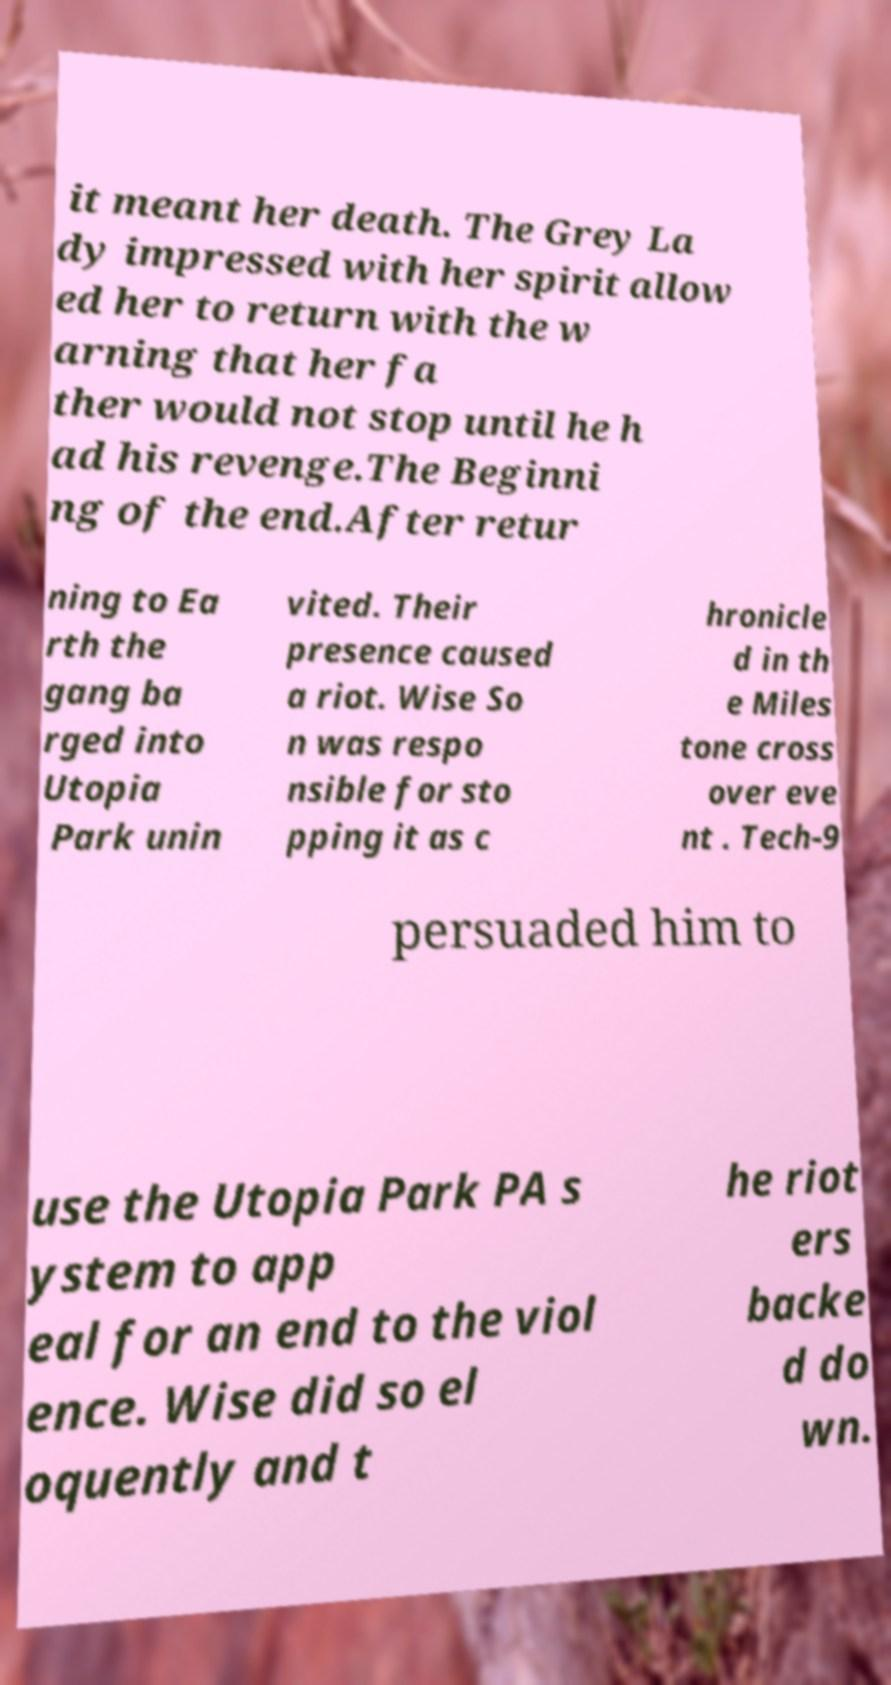For documentation purposes, I need the text within this image transcribed. Could you provide that? it meant her death. The Grey La dy impressed with her spirit allow ed her to return with the w arning that her fa ther would not stop until he h ad his revenge.The Beginni ng of the end.After retur ning to Ea rth the gang ba rged into Utopia Park unin vited. Their presence caused a riot. Wise So n was respo nsible for sto pping it as c hronicle d in th e Miles tone cross over eve nt . Tech-9 persuaded him to use the Utopia Park PA s ystem to app eal for an end to the viol ence. Wise did so el oquently and t he riot ers backe d do wn. 